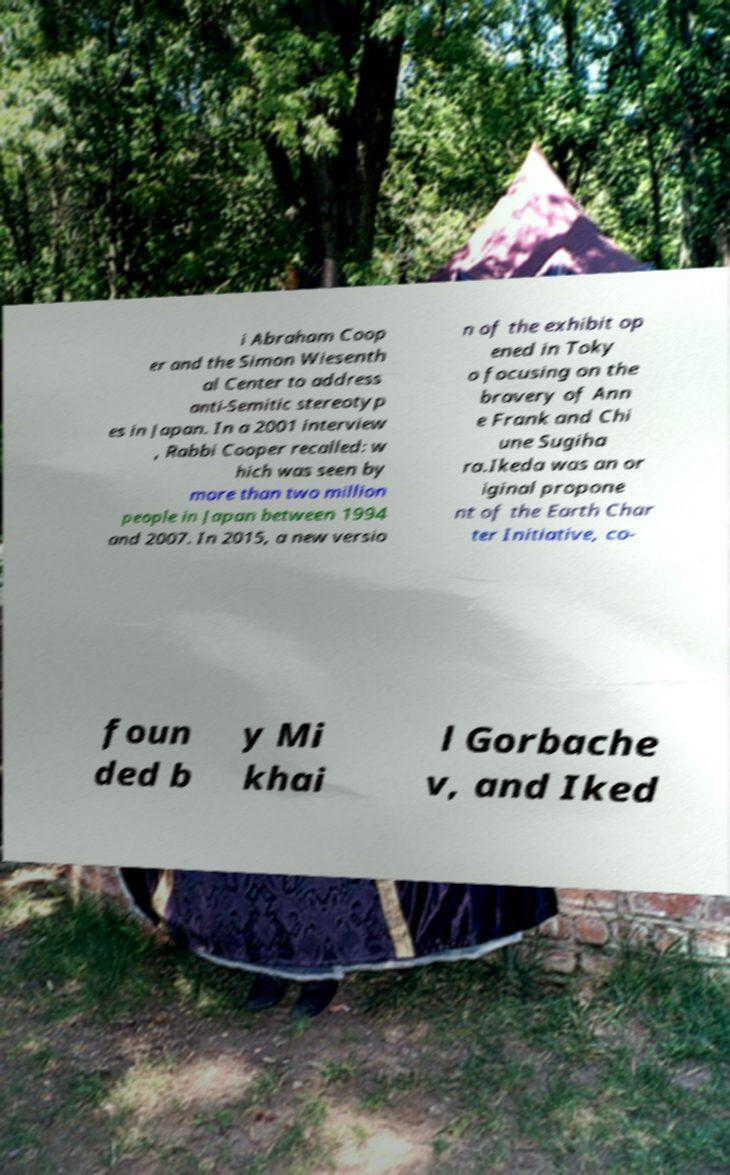Please read and relay the text visible in this image. What does it say? i Abraham Coop er and the Simon Wiesenth al Center to address anti-Semitic stereotyp es in Japan. In a 2001 interview , Rabbi Cooper recalled: w hich was seen by more than two million people in Japan between 1994 and 2007. In 2015, a new versio n of the exhibit op ened in Toky o focusing on the bravery of Ann e Frank and Chi une Sugiha ra.Ikeda was an or iginal propone nt of the Earth Char ter Initiative, co- foun ded b y Mi khai l Gorbache v, and Iked 